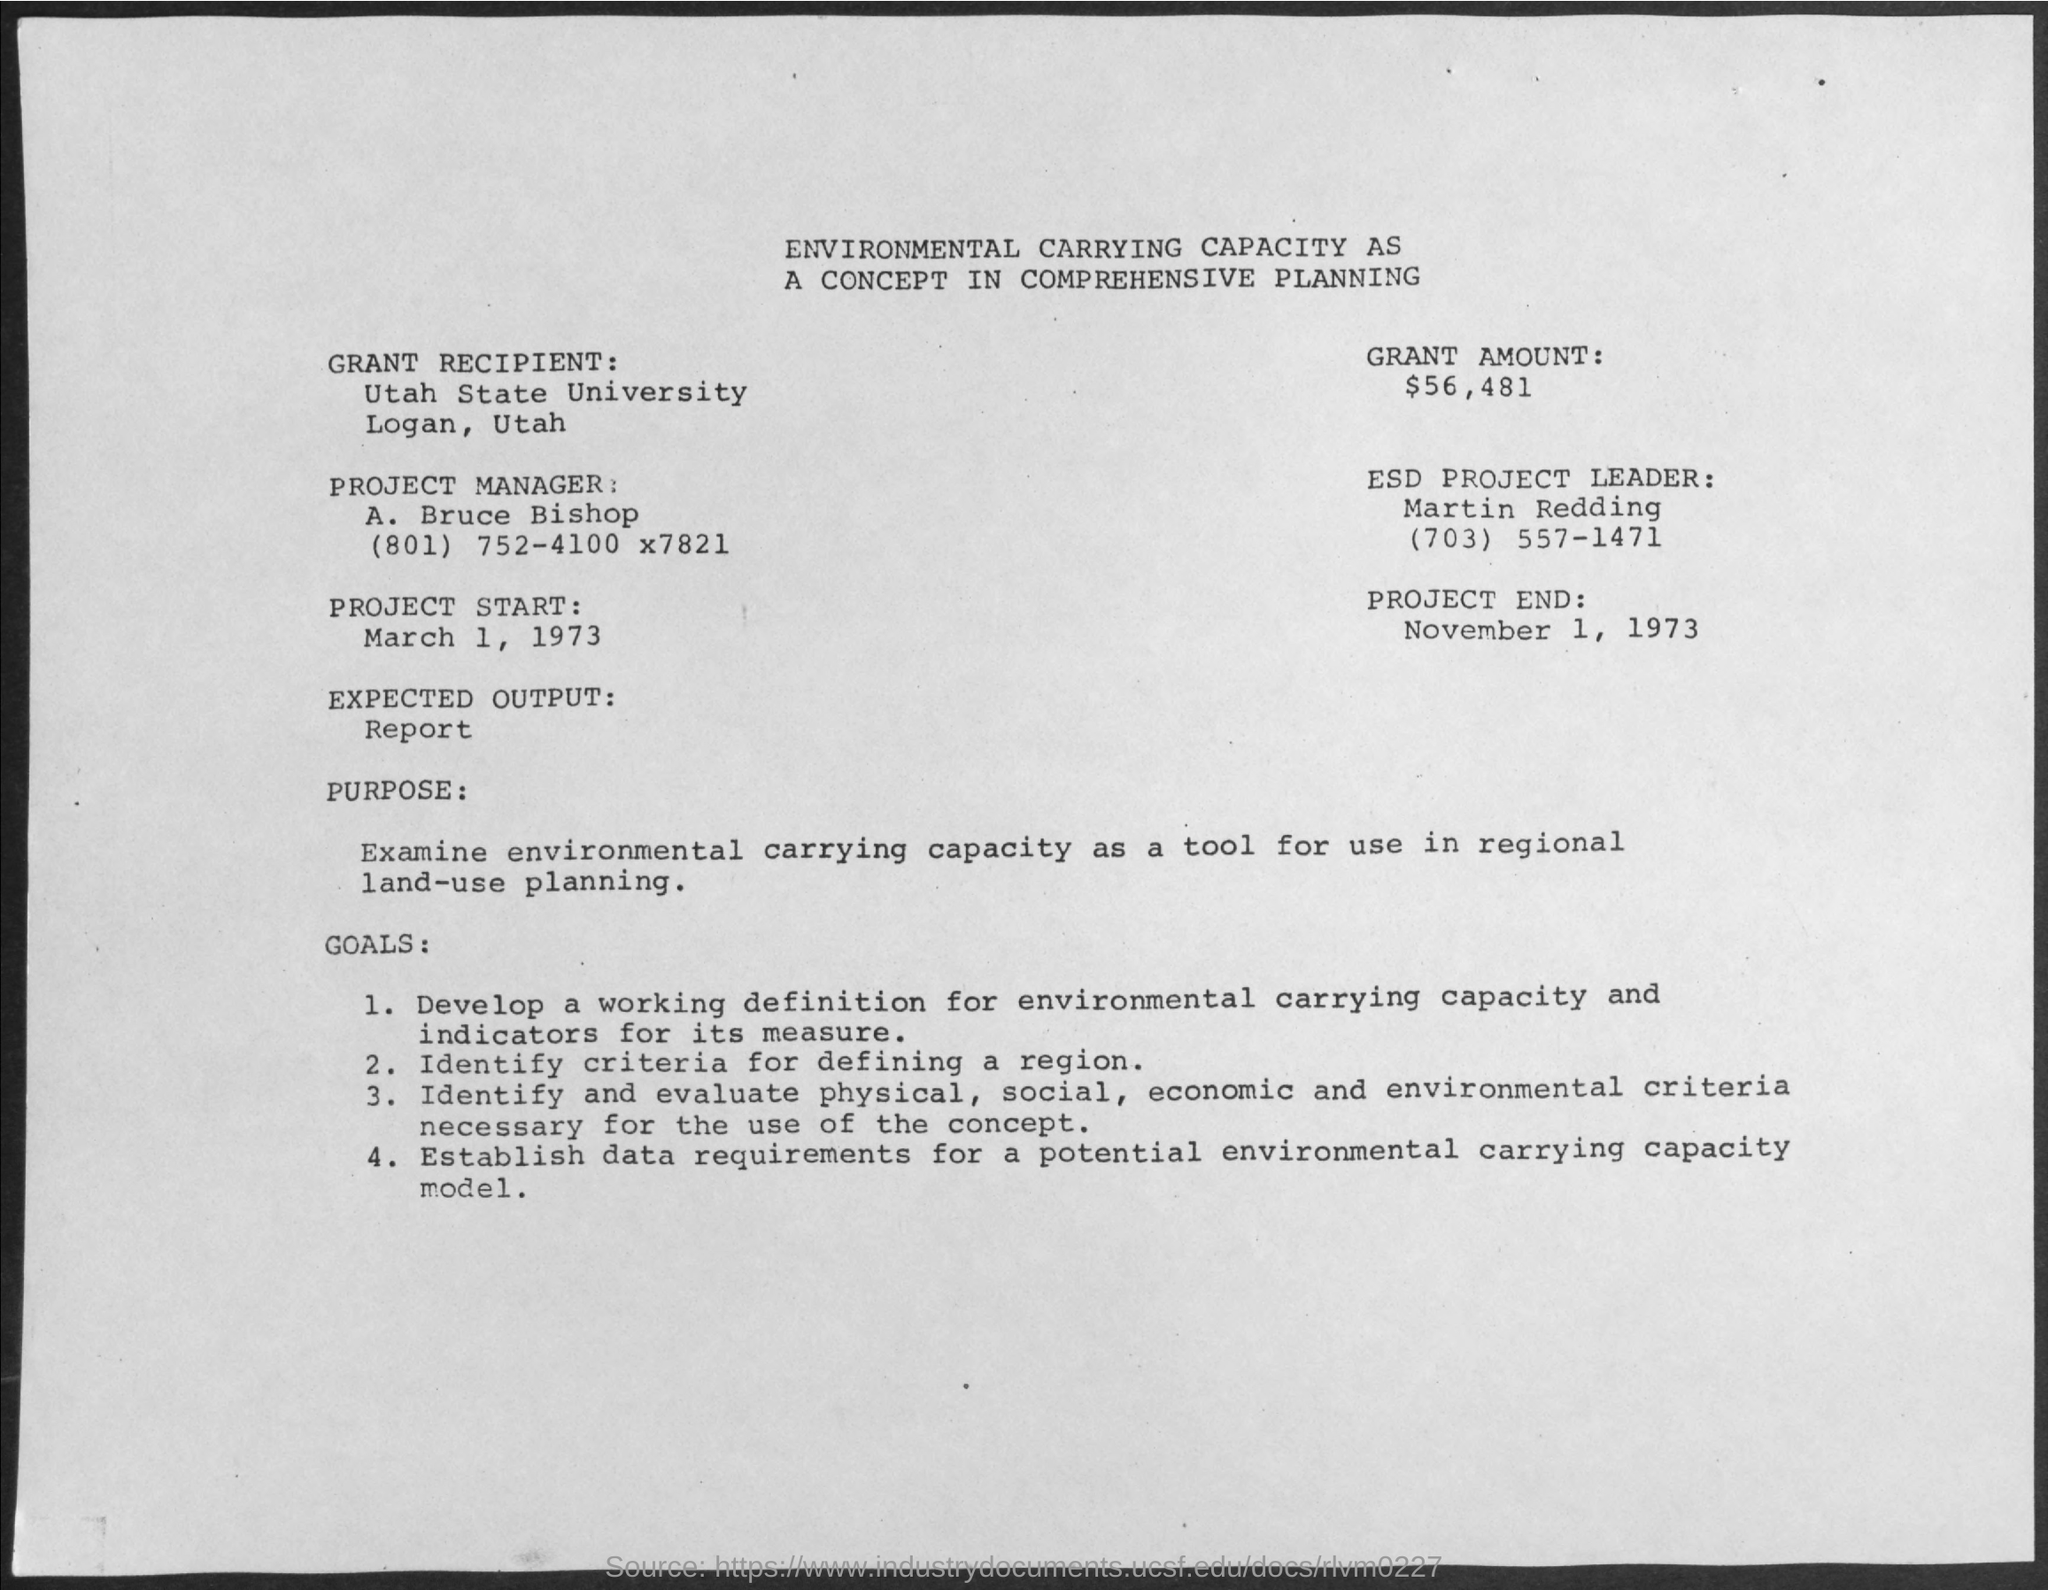Who is the Grant Recipient?
Keep it short and to the point. Utah State University, Logan, Utah. What is the Grant Amount?
Give a very brief answer. $56,481. Who is the Project Manager?
Keep it short and to the point. A. Bruce Bishop. When does the Project Start?
Your answer should be compact. March 1, 1973. When does the Project End?
Keep it short and to the point. November 1, 1973. What is the Expected Output?
Provide a short and direct response. Report. 